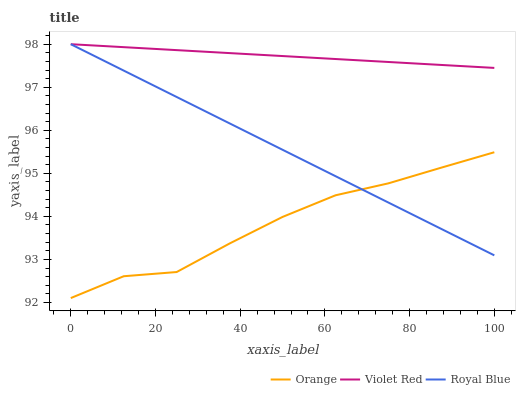Does Orange have the minimum area under the curve?
Answer yes or no. Yes. Does Violet Red have the maximum area under the curve?
Answer yes or no. Yes. Does Royal Blue have the minimum area under the curve?
Answer yes or no. No. Does Royal Blue have the maximum area under the curve?
Answer yes or no. No. Is Violet Red the smoothest?
Answer yes or no. Yes. Is Orange the roughest?
Answer yes or no. Yes. Is Royal Blue the smoothest?
Answer yes or no. No. Is Royal Blue the roughest?
Answer yes or no. No. Does Orange have the lowest value?
Answer yes or no. Yes. Does Royal Blue have the lowest value?
Answer yes or no. No. Does Violet Red have the highest value?
Answer yes or no. Yes. Is Orange less than Violet Red?
Answer yes or no. Yes. Is Violet Red greater than Orange?
Answer yes or no. Yes. Does Royal Blue intersect Orange?
Answer yes or no. Yes. Is Royal Blue less than Orange?
Answer yes or no. No. Is Royal Blue greater than Orange?
Answer yes or no. No. Does Orange intersect Violet Red?
Answer yes or no. No. 